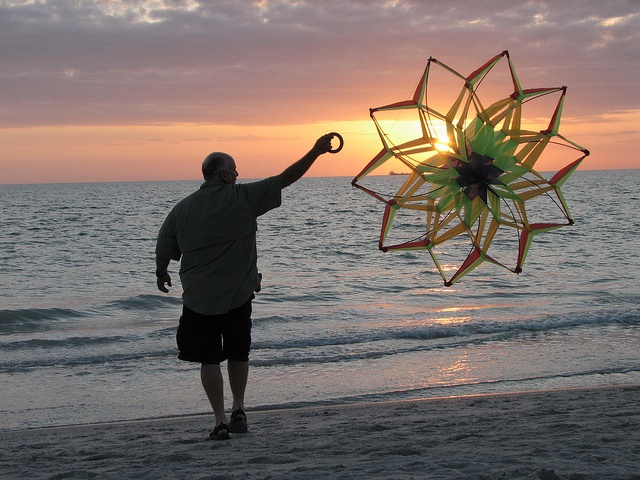Describe the objects in this image and their specific colors. I can see kite in darkgray, olive, tan, and gray tones and people in darkgray, black, gray, and tan tones in this image. 